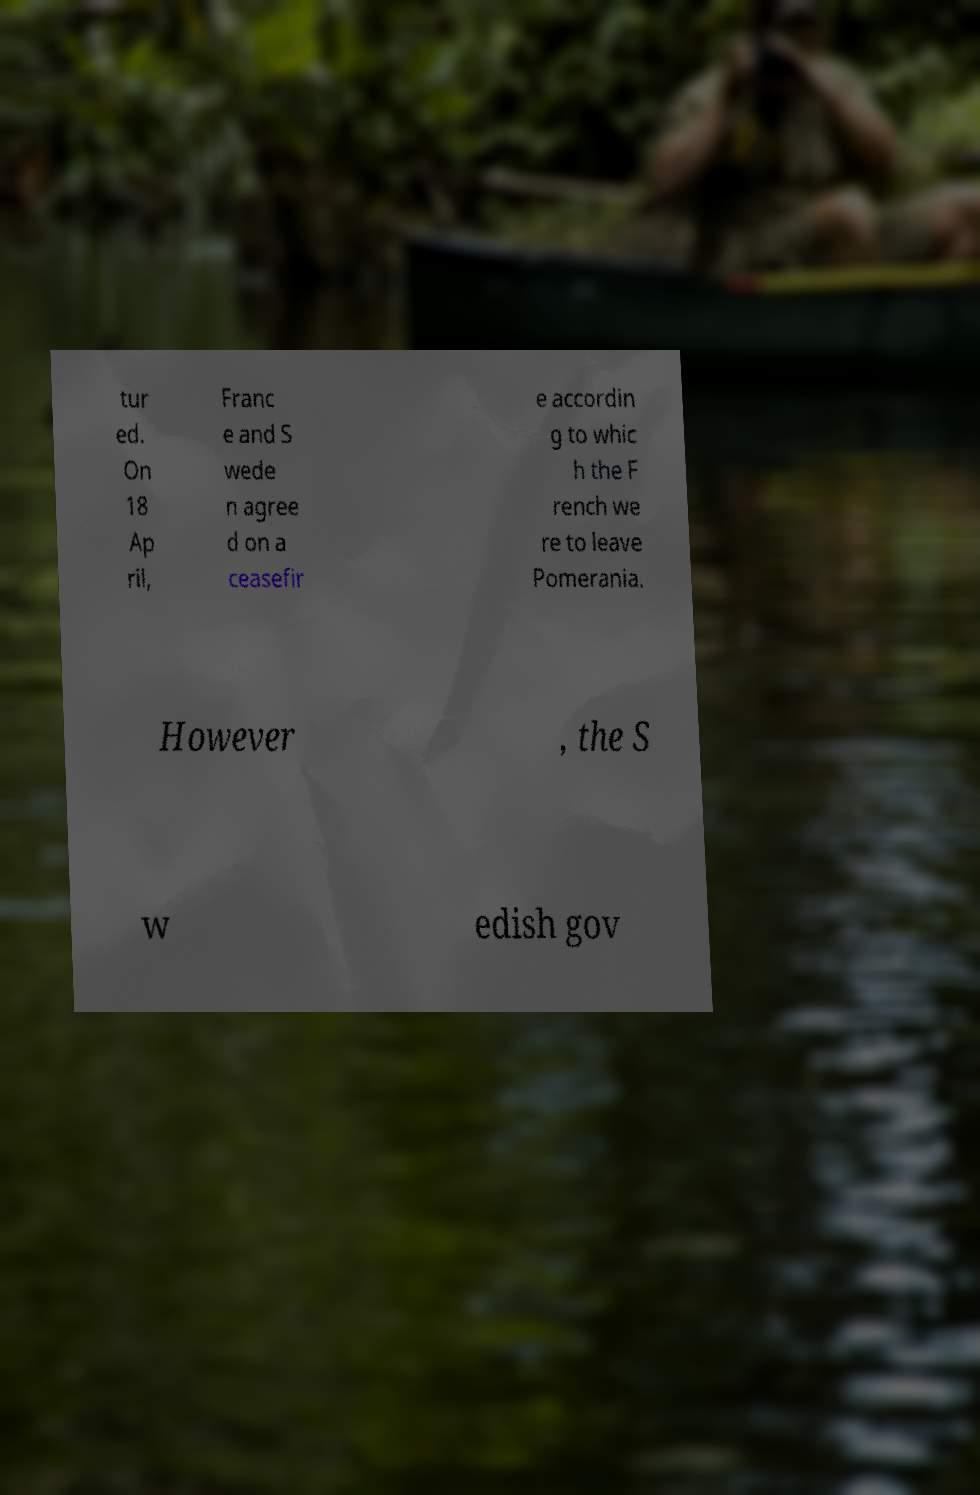Can you read and provide the text displayed in the image?This photo seems to have some interesting text. Can you extract and type it out for me? tur ed. On 18 Ap ril, Franc e and S wede n agree d on a ceasefir e accordin g to whic h the F rench we re to leave Pomerania. However , the S w edish gov 